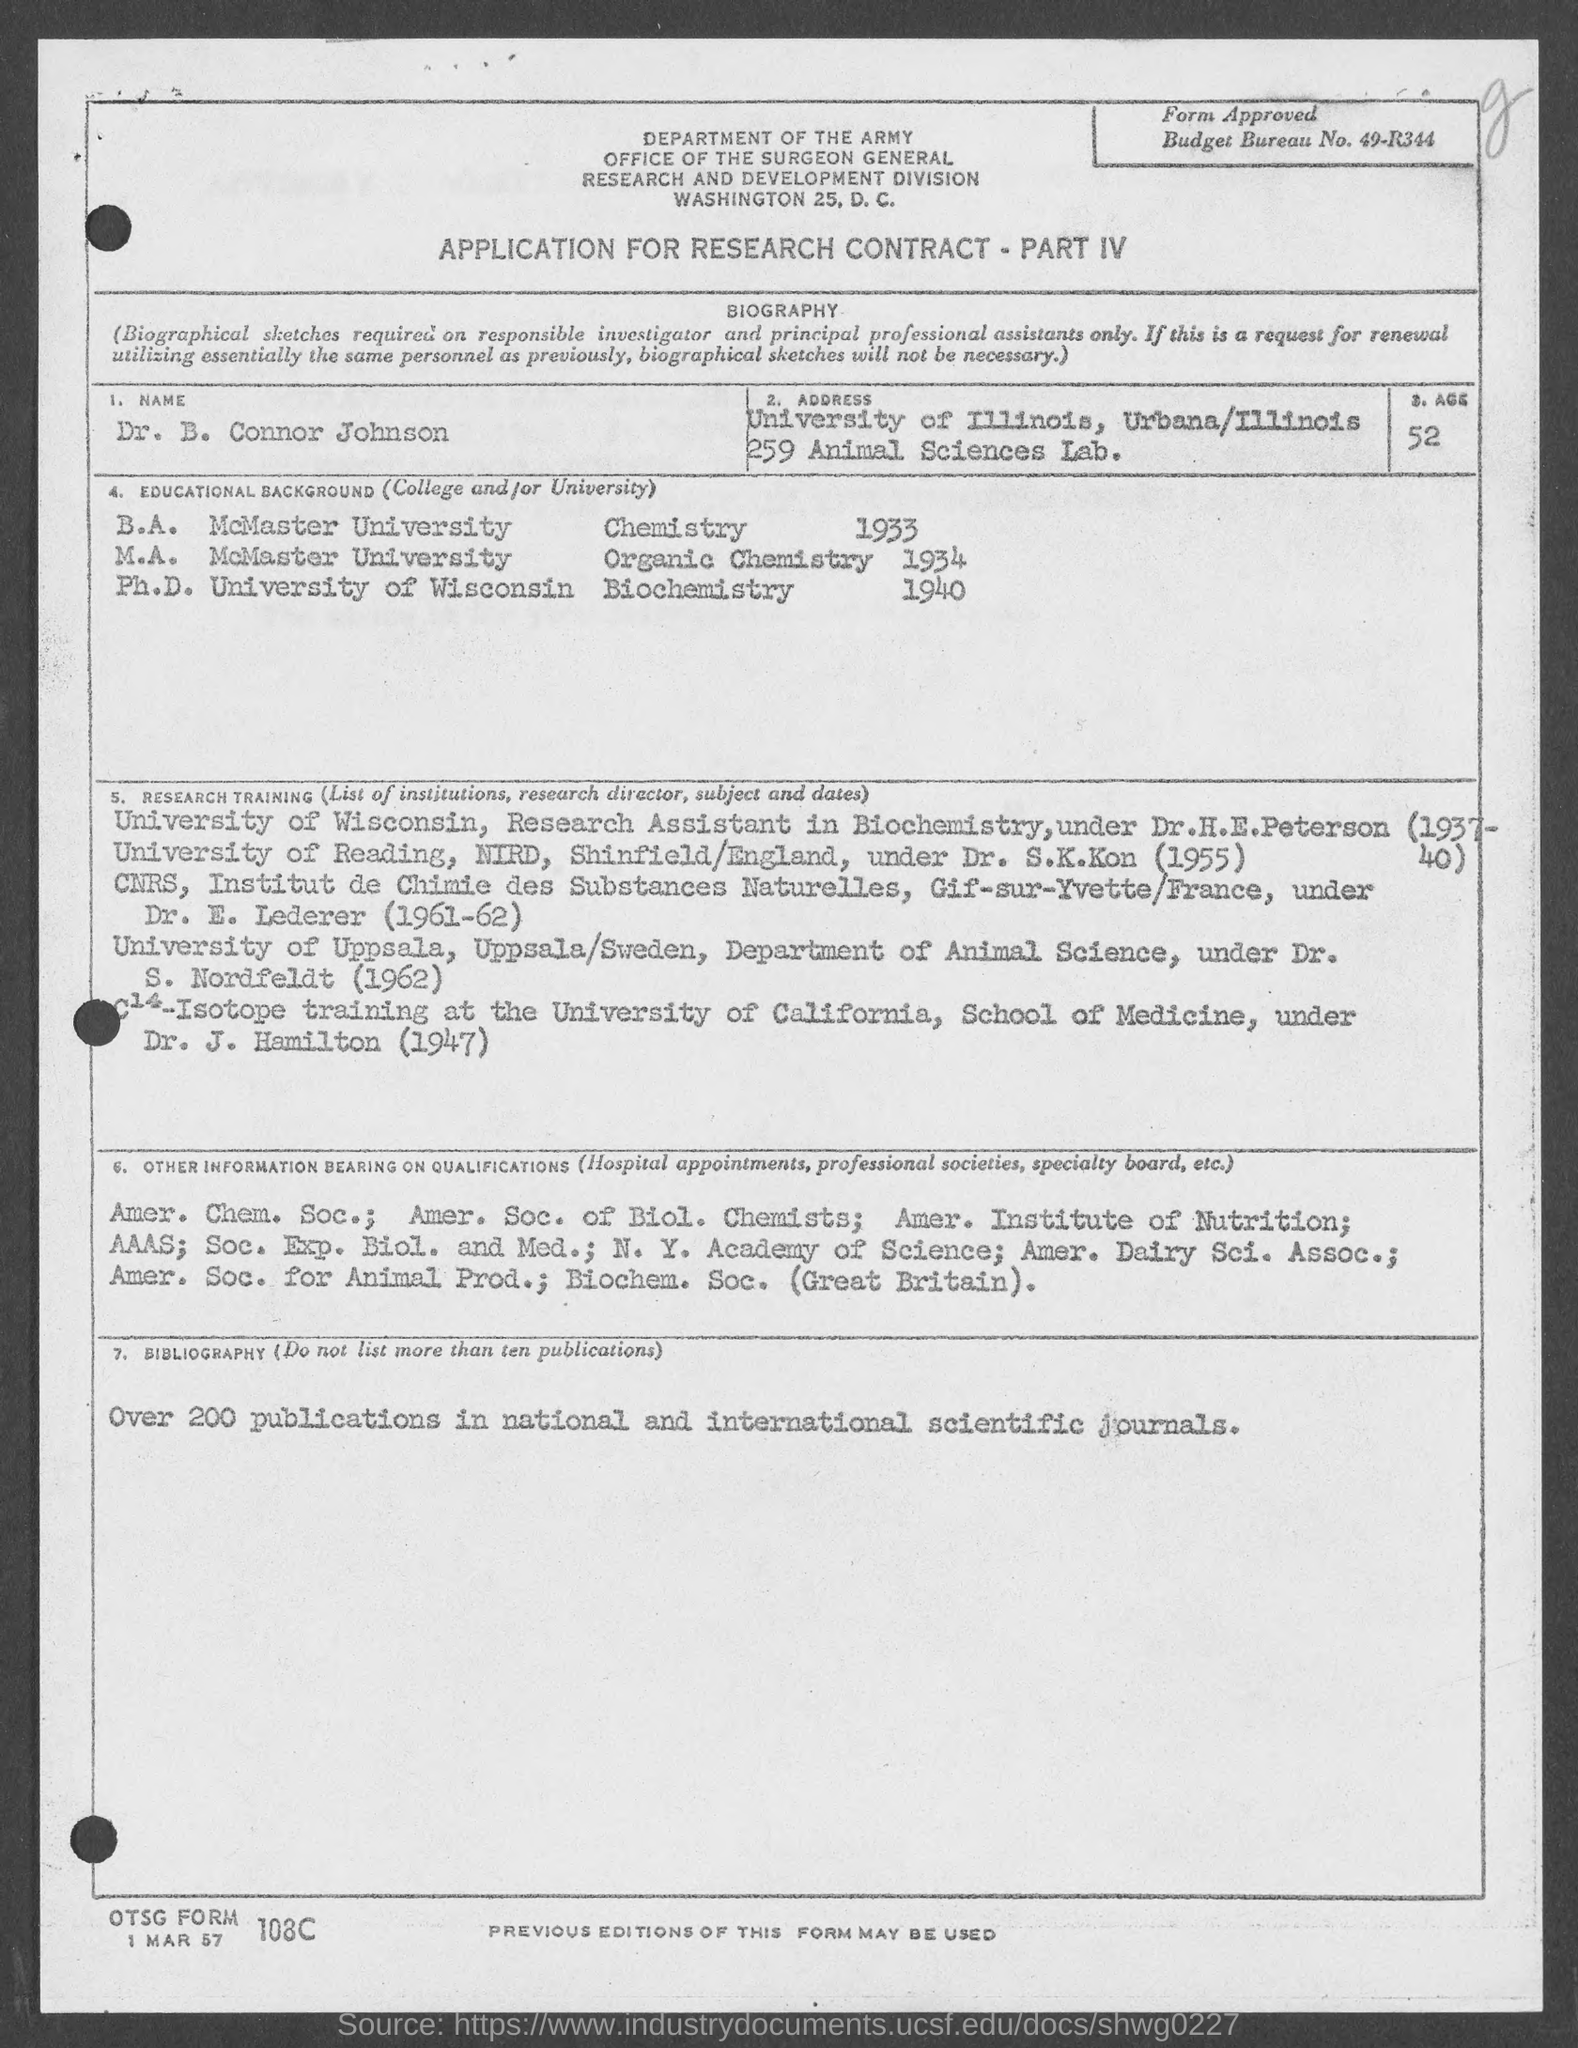Identify some key points in this picture. The age of Dr. B. Connor Johnson, as per the application, is 52. Dr. B. Connor Johnson earned his Ph.D. in Biochemistry from the University of Wisconsin. Dr. B. Connor Johnson completed his M.A. degree in Organic Chemistry in 1934. Dr. B. Connor Johnson worked as a Research Assistant in Biochemistry under Dr. H.E. Peterson during the period of 1937-40. The Budget Bureau Number specified in the application is 49-R344... 